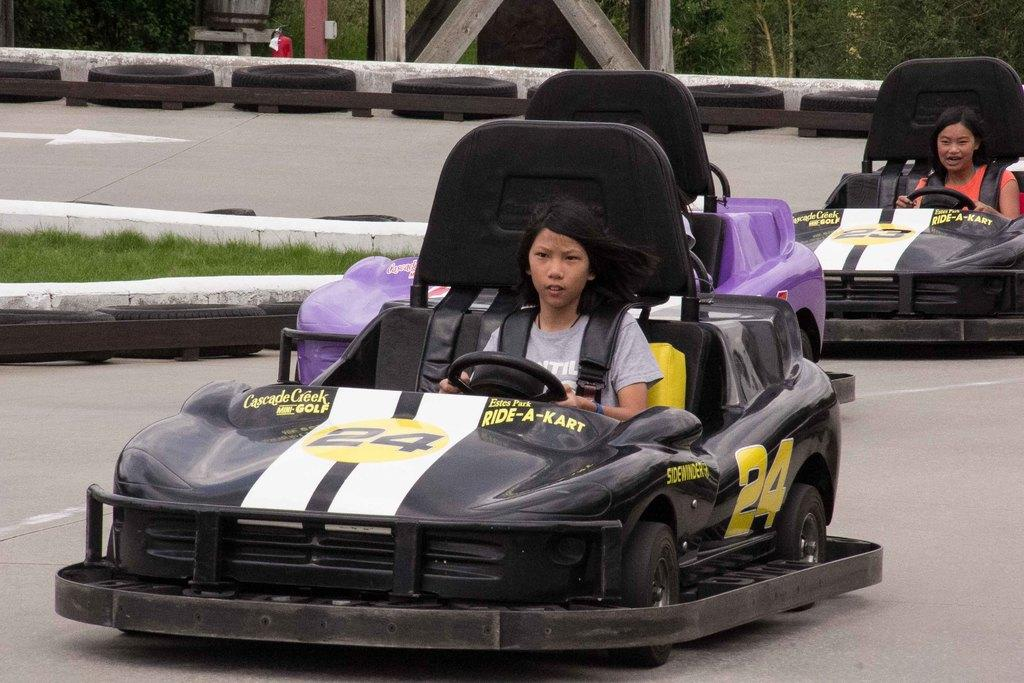How many people are in the image? There are two girls in the image. What are the girls doing in the image? The girls are driving a car in the image. What can be seen in the background of the image? There are many trees at the top of the image. What else can be seen on the road in the image? There are tires placed aside on the road in the image. What type of butter is being used to cast the tires in the image? There is no butter or casting of tires present in the image. 